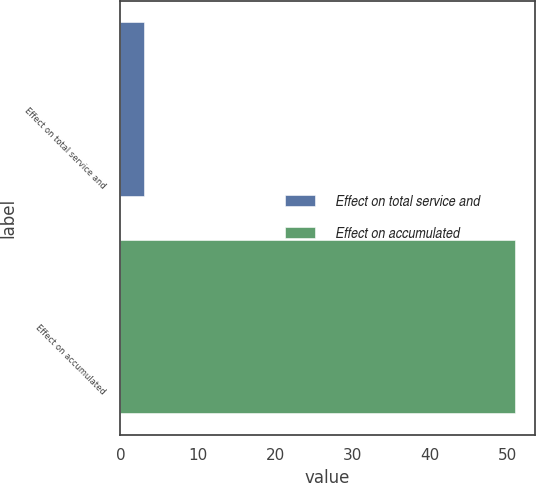Convert chart to OTSL. <chart><loc_0><loc_0><loc_500><loc_500><bar_chart><fcel>Effect on total service and<fcel>Effect on accumulated<nl><fcel>3<fcel>51<nl></chart> 